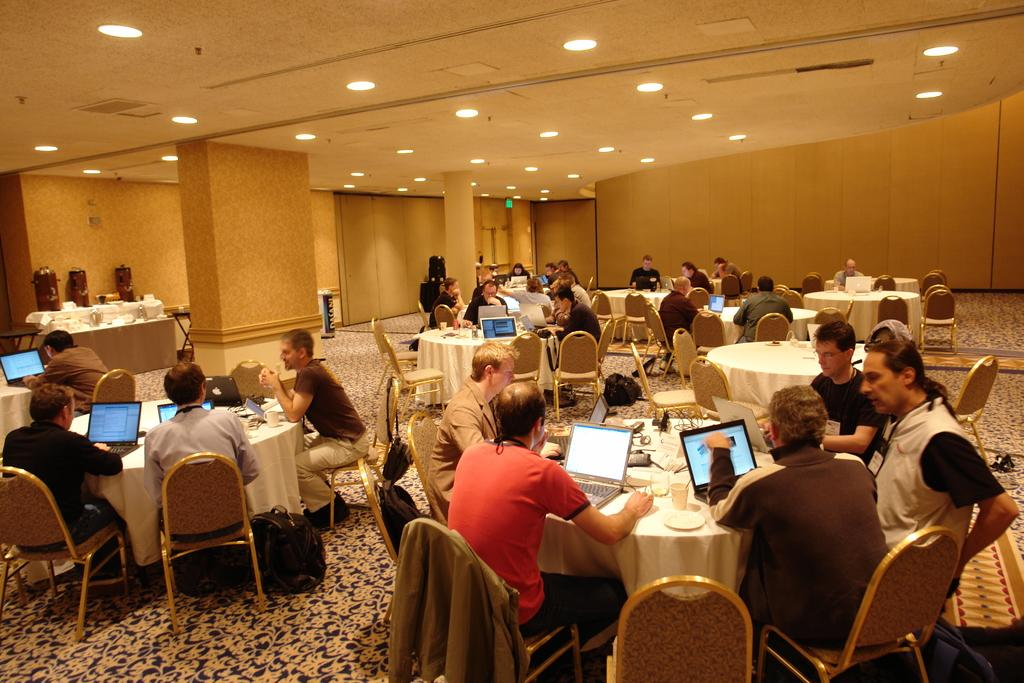How many people are in the image? There are many people in the image. What are the people doing in the image? The people are sitting in chairs. What can be seen on the table in the image? Laptops, glasses, and food items are on the table. What is visible in the background of the image? There is a wall in the background. What architectural feature is present in the image? There is a pillar in the image. What type of fowl is sitting on the table in the image? There is no fowl present on the table in the image. How does the twist in the image affect the people's seating arrangement? There is no twist present in the image, so it does not affect the people's seating arrangement. 